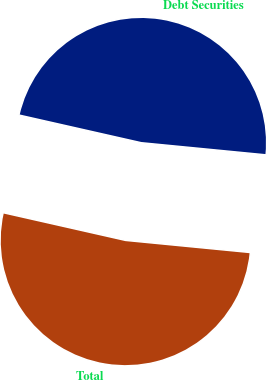Convert chart. <chart><loc_0><loc_0><loc_500><loc_500><pie_chart><fcel>Debt Securities<fcel>Total<nl><fcel>48.0%<fcel>52.0%<nl></chart> 